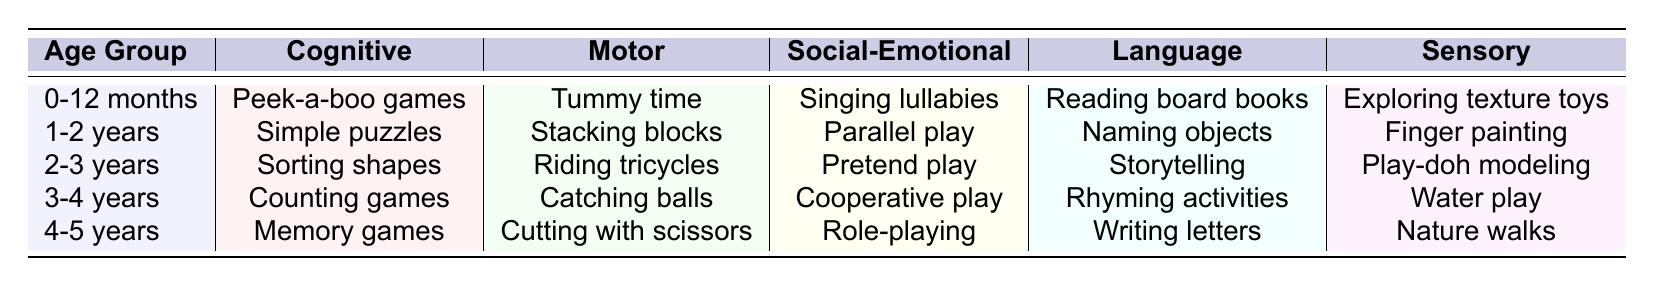What activity is suggested for the 2-3 years age group under the sensory category? In the table, I look under the "Age Group" section for "2-3 years" and then check the corresponding "Sensory" column, which indicates "Play-doh modeling."
Answer: Play-doh modeling What is the cognitive activity for children aged 1-2 years? For children aged "1-2 years," I refer to the "Cognitive" column in the table, which shows "Simple puzzles" as the activity.
Answer: Simple puzzles Is "Tummy time" an activity for children aged 0-12 months? To find out, I check the corresponding row for the "0-12 months" age group and see that "Tummy time" is listed as a motor activity. Therefore, the statement is true.
Answer: Yes What are the social-emotional activities listed for 3-4 years? I locate the "3-4 years" row in the table and observe that the social-emotional activity mentioned is "Cooperative play."
Answer: Cooperative play How many different types of activities are suggested for the 4-5 years age group? The age group "4-5 years" corresponds to five different categories: cognitive, motor, social-emotional, language, and sensory, leading to a total of 5 suggested activities.
Answer: 5 Which age group has the activity "Counting games"? I search through the table, looking for the "Cognitive" activities, and find that "Counting games" is listed under the "3-4 years" age group.
Answer: 3-4 years What would be the difference in the cognitive activities between 1-2 years and 3-4 years age groups? The cognitive activity for "1-2 years" is "Simple puzzles," while for "3-4 years," it is "Counting games." Hence, no numerical difference exists; they are simply different activities.
Answer: Different activities Can you list all the sensory activities mentioned for each age group? I check each age group's sensory activity in the table: for 0-12 months it is "Exploring texture toys," for 1-2 years it is "Finger painting," for 2-3 years it's "Play-doh modeling," for 3-4 years it's "Water play," and for 4-5 years it's "Nature walks."
Answer: Exploring texture toys, Finger painting, Play-doh modeling, Water play, Nature walks Which two age groups have activities involving "Cooperative play" and "Parallel play"? Looking at the "Social-Emotional" section of the table, I find that "Cooperative play" is in the "3-4 years" row and "Parallel play" is found in the "1-2 years" row. Hence, the two age groups are 1-2 years and 3-4 years.
Answer: 1-2 years and 3-4 years Is there any overlap in activities between the 2-3 years and 4-5 years age groups in the cognitive category? By comparing the "Cognitive" activities, I see that "Sorting shapes" for 2-3 years and "Memory games" for 4-5 years are different, indicating no overlap in activities for those age groups.
Answer: No 